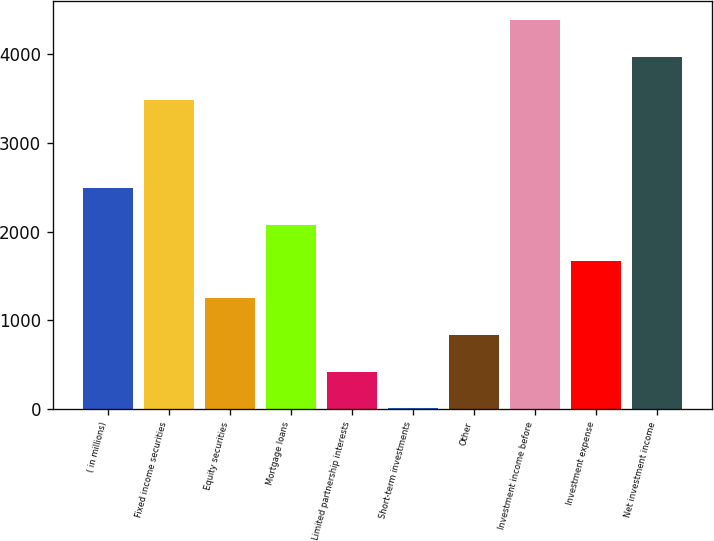Convert chart to OTSL. <chart><loc_0><loc_0><loc_500><loc_500><bar_chart><fcel>( in millions)<fcel>Fixed income securities<fcel>Equity securities<fcel>Mortgage loans<fcel>Limited partnership interests<fcel>Short-term investments<fcel>Other<fcel>Investment income before<fcel>Investment expense<fcel>Net investment income<nl><fcel>2494.8<fcel>3484<fcel>1250.4<fcel>2080<fcel>420.8<fcel>6<fcel>835.6<fcel>4385.8<fcel>1665.2<fcel>3971<nl></chart> 